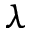<formula> <loc_0><loc_0><loc_500><loc_500>\lambda</formula> 